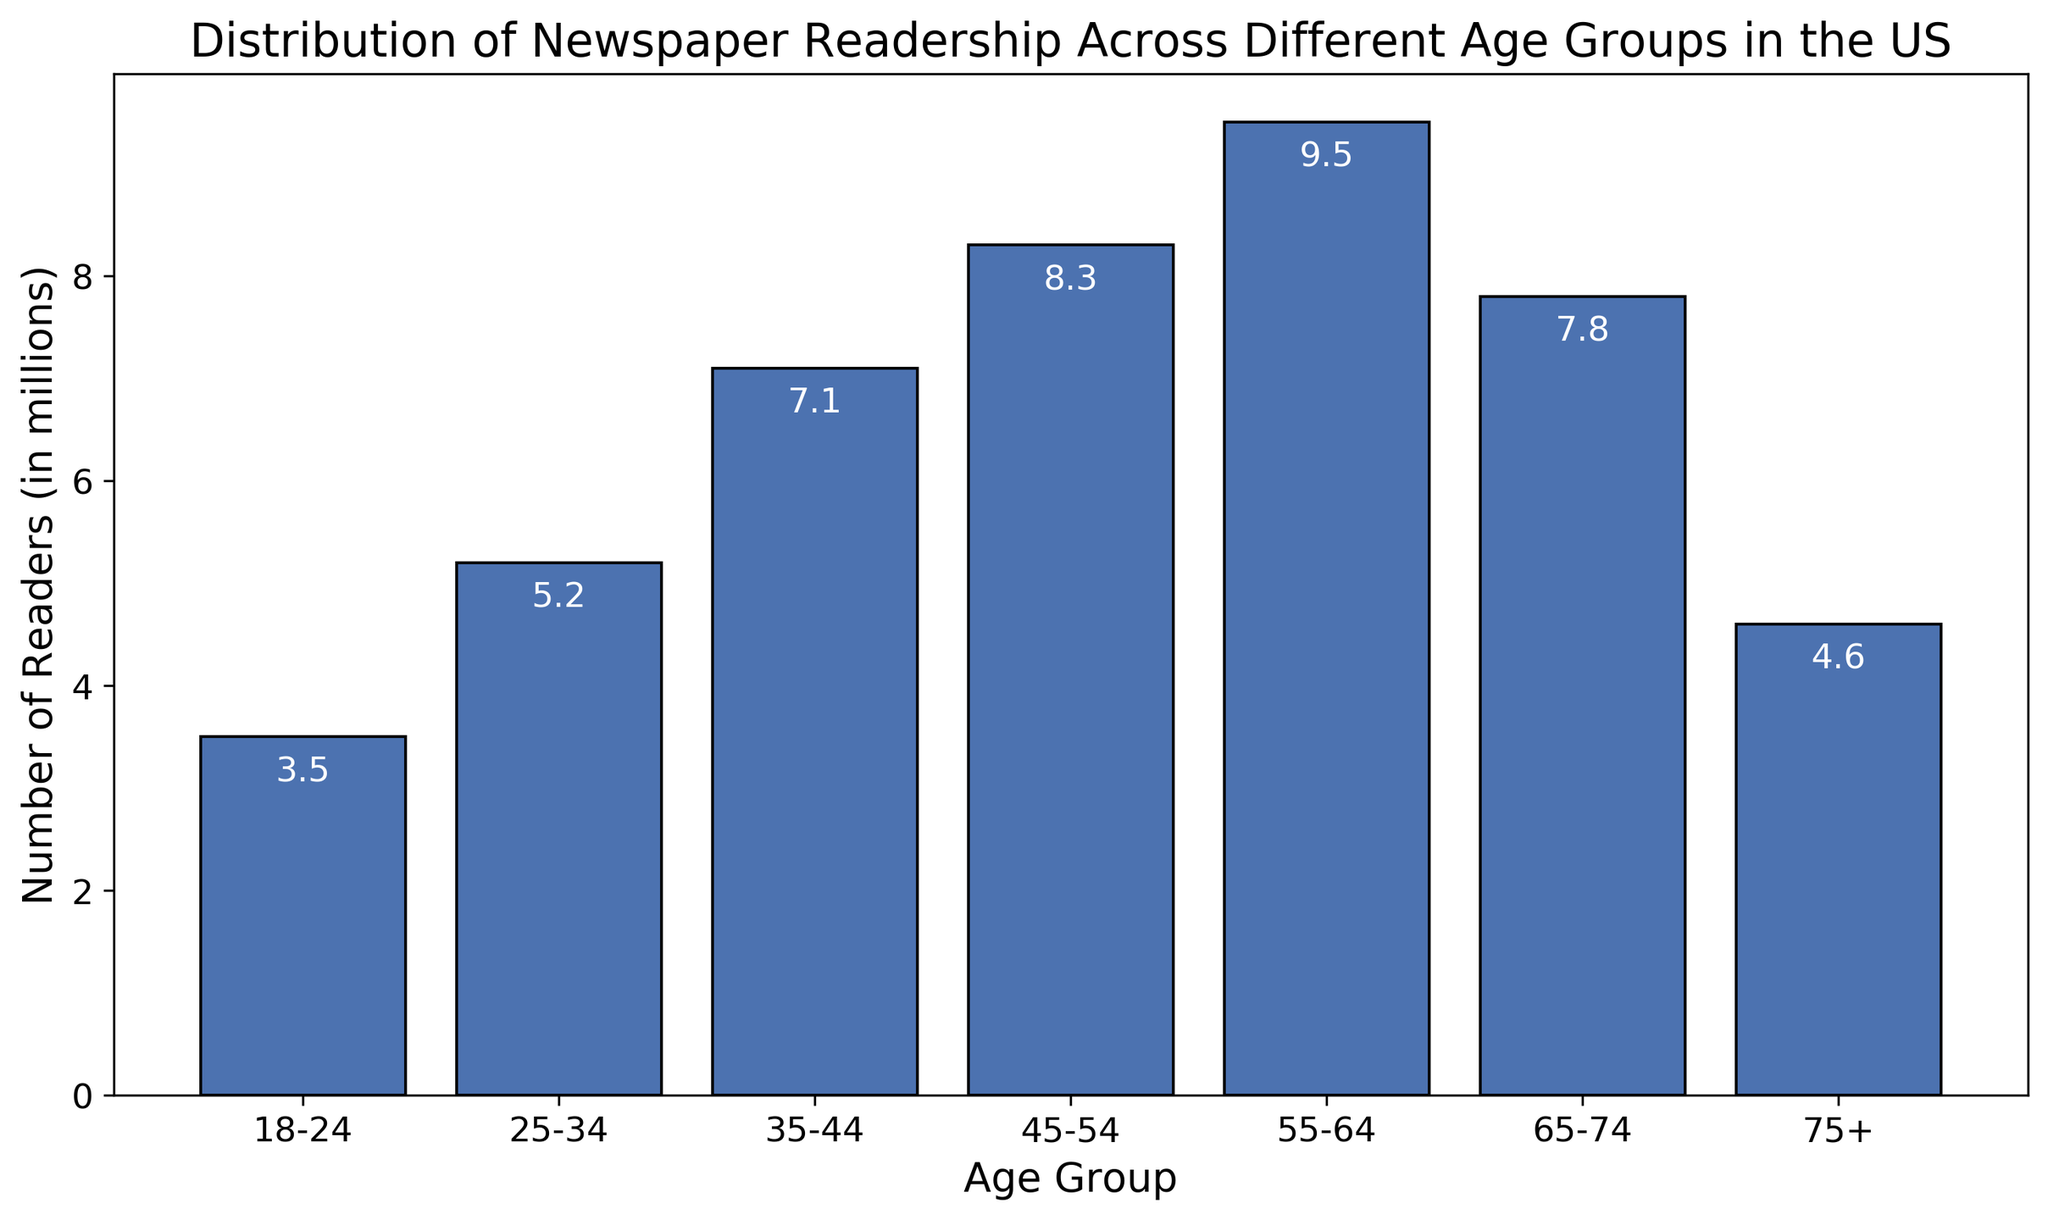Which age group has the highest number of newspaper readers? The age group with the highest bar represents the most readers. The bar for the 55-64 age group is the tallest at 9.5 million readers.
Answer: 55-64 Which age group has the lowest number of newspaper readers? The age group with the shortest bar represents the fewest readers. The bar for the 18-24 age group is the shortest at 3.5 million readers.
Answer: 18-24 What are the total number of readers for the age groups 18-24 and 25-34 combined? Add the readership numbers for both groups: 3.5 million (18-24) + 5.2 million (25-34) = 8.7 million.
Answer: 8.7 million How many more readers are there in the 55-64 age group compared to the 65-74 age group? Subtract the readership of the 65-74 group from the 55-64 group: 9.5 million - 7.8 million = 1.7 million.
Answer: 1.7 million What is the combined number of readers for the age groups 45-54 and 75+? Add the readership numbers for both groups: 8.3 million (45-54) + 4.6 million (75+) = 12.9 million.
Answer: 12.9 million Between which two consecutive age groups is the increase in readership the highest? Calculate the differences between consecutive age groups: 
(25-34) 5.2 - 3.5 = 1.7, 
(35-44) 7.1 - 5.2 = 1.9, 
(45-54) 8.3 - 7.1 = 1.2, 
(55-64) 9.5 - 8.3 = 1.2, 
(65-74) 7.8 - 9.5 = -1.7, 
(75+) 4.6 - 7.8 = -3.2.
The highest increase is between 25-34 and 35-44 at 1.9 million.
Answer: 25-34 to 35-44 What is the difference in readership between the age groups 35-44 and 45-54? Subtract the readership of the 35-44 group from the 45-54 group: 8.3 million - 7.1 million = 1.2 million.
Answer: 1.2 million What is the average readership across all age groups? Add all readership numbers and divide by the number of age groups: (3.5 + 5.2 + 7.1 + 8.3 + 9.5 + 7.8 + 4.6) / 7 = 46 / 7 ≈ 6.57 million.
Answer: 6.57 million 